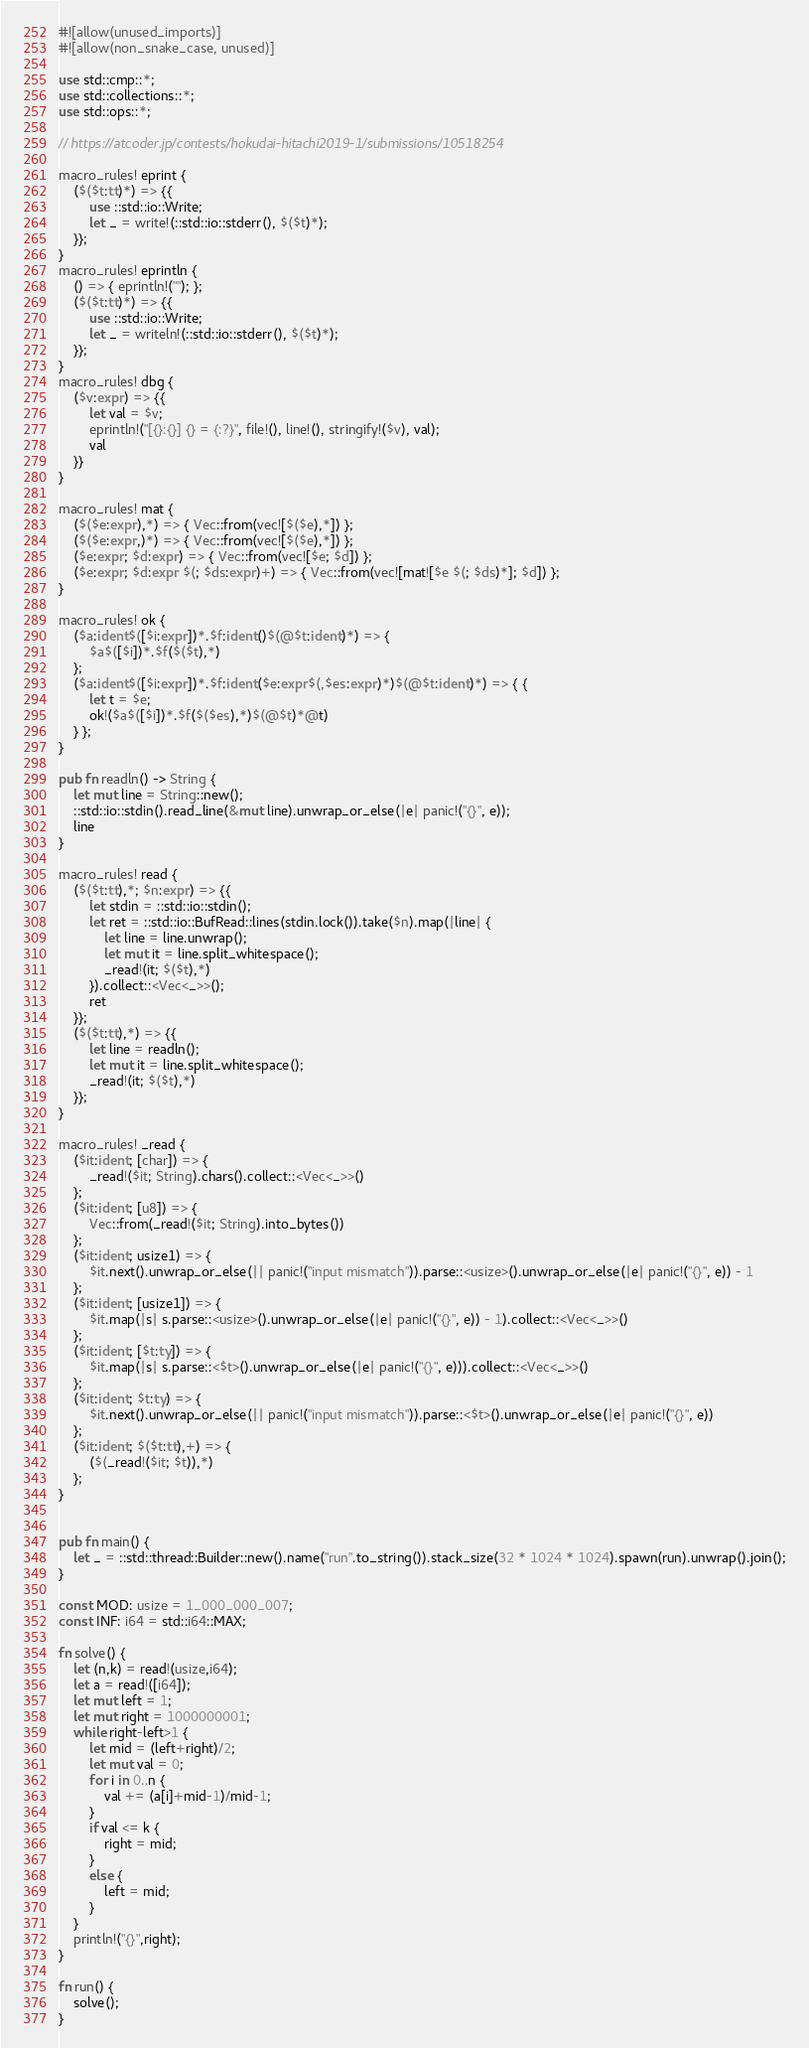Convert code to text. <code><loc_0><loc_0><loc_500><loc_500><_Rust_>#![allow(unused_imports)]
#![allow(non_snake_case, unused)]

use std::cmp::*;
use std::collections::*;
use std::ops::*;

// https://atcoder.jp/contests/hokudai-hitachi2019-1/submissions/10518254

macro_rules! eprint {
    ($($t:tt)*) => {{
        use ::std::io::Write;
        let _ = write!(::std::io::stderr(), $($t)*);
    }};
}
macro_rules! eprintln {
    () => { eprintln!(""); };
    ($($t:tt)*) => {{
        use ::std::io::Write;
        let _ = writeln!(::std::io::stderr(), $($t)*);
    }};
}
macro_rules! dbg {
    ($v:expr) => {{
        let val = $v;
        eprintln!("[{}:{}] {} = {:?}", file!(), line!(), stringify!($v), val);
        val
    }}
}

macro_rules! mat {
    ($($e:expr),*) => { Vec::from(vec![$($e),*]) };
    ($($e:expr,)*) => { Vec::from(vec![$($e),*]) };
    ($e:expr; $d:expr) => { Vec::from(vec![$e; $d]) };
    ($e:expr; $d:expr $(; $ds:expr)+) => { Vec::from(vec![mat![$e $(; $ds)*]; $d]) };
}

macro_rules! ok {
    ($a:ident$([$i:expr])*.$f:ident()$(@$t:ident)*) => {
        $a$([$i])*.$f($($t),*)
    };
    ($a:ident$([$i:expr])*.$f:ident($e:expr$(,$es:expr)*)$(@$t:ident)*) => { {
        let t = $e;
        ok!($a$([$i])*.$f($($es),*)$(@$t)*@t)
    } };
}

pub fn readln() -> String {
    let mut line = String::new();
    ::std::io::stdin().read_line(&mut line).unwrap_or_else(|e| panic!("{}", e));
    line
}

macro_rules! read {
    ($($t:tt),*; $n:expr) => {{
        let stdin = ::std::io::stdin();
        let ret = ::std::io::BufRead::lines(stdin.lock()).take($n).map(|line| {
            let line = line.unwrap();
            let mut it = line.split_whitespace();
            _read!(it; $($t),*)
        }).collect::<Vec<_>>();
        ret
    }};
    ($($t:tt),*) => {{
        let line = readln();
        let mut it = line.split_whitespace();
        _read!(it; $($t),*)
    }};
}

macro_rules! _read {
    ($it:ident; [char]) => {
        _read!($it; String).chars().collect::<Vec<_>>()
    };
    ($it:ident; [u8]) => {
        Vec::from(_read!($it; String).into_bytes())
    };
    ($it:ident; usize1) => {
        $it.next().unwrap_or_else(|| panic!("input mismatch")).parse::<usize>().unwrap_or_else(|e| panic!("{}", e)) - 1
    };
    ($it:ident; [usize1]) => {
        $it.map(|s| s.parse::<usize>().unwrap_or_else(|e| panic!("{}", e)) - 1).collect::<Vec<_>>()
    };
    ($it:ident; [$t:ty]) => {
        $it.map(|s| s.parse::<$t>().unwrap_or_else(|e| panic!("{}", e))).collect::<Vec<_>>()
    };
    ($it:ident; $t:ty) => {
        $it.next().unwrap_or_else(|| panic!("input mismatch")).parse::<$t>().unwrap_or_else(|e| panic!("{}", e))
    };
    ($it:ident; $($t:tt),+) => {
        ($(_read!($it; $t)),*)
    };
}


pub fn main() {
    let _ = ::std::thread::Builder::new().name("run".to_string()).stack_size(32 * 1024 * 1024).spawn(run).unwrap().join();
}

const MOD: usize = 1_000_000_007;
const INF: i64 = std::i64::MAX;

fn solve() {
    let (n,k) = read!(usize,i64);
    let a = read!([i64]);
    let mut left = 1;
    let mut right = 1000000001;
    while right-left>1 {
        let mid = (left+right)/2;
        let mut val = 0;
        for i in 0..n {
            val += (a[i]+mid-1)/mid-1;
        }
        if val <= k {
            right = mid;
        }
        else {
            left = mid;
        }
    }
    println!("{}",right);
}

fn run() {
    solve();
}
</code> 